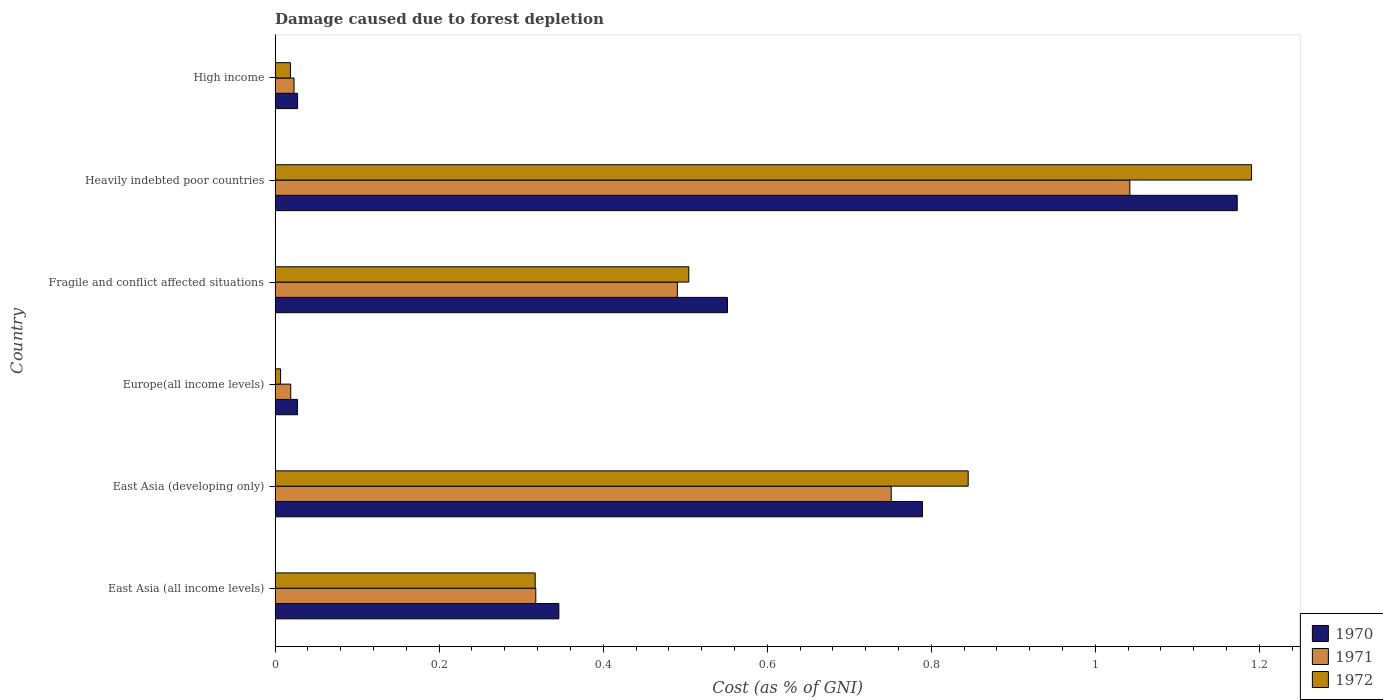How many groups of bars are there?
Your answer should be compact. 6. Are the number of bars per tick equal to the number of legend labels?
Make the answer very short. Yes. How many bars are there on the 1st tick from the top?
Offer a terse response. 3. What is the label of the 4th group of bars from the top?
Give a very brief answer. Europe(all income levels). In how many cases, is the number of bars for a given country not equal to the number of legend labels?
Offer a very short reply. 0. What is the cost of damage caused due to forest depletion in 1971 in East Asia (all income levels)?
Give a very brief answer. 0.32. Across all countries, what is the maximum cost of damage caused due to forest depletion in 1971?
Make the answer very short. 1.04. Across all countries, what is the minimum cost of damage caused due to forest depletion in 1972?
Offer a terse response. 0.01. In which country was the cost of damage caused due to forest depletion in 1972 maximum?
Ensure brevity in your answer.  Heavily indebted poor countries. In which country was the cost of damage caused due to forest depletion in 1971 minimum?
Your answer should be compact. Europe(all income levels). What is the total cost of damage caused due to forest depletion in 1970 in the graph?
Your response must be concise. 2.91. What is the difference between the cost of damage caused due to forest depletion in 1971 in Fragile and conflict affected situations and that in Heavily indebted poor countries?
Your response must be concise. -0.55. What is the difference between the cost of damage caused due to forest depletion in 1971 in Heavily indebted poor countries and the cost of damage caused due to forest depletion in 1970 in East Asia (developing only)?
Your answer should be very brief. 0.25. What is the average cost of damage caused due to forest depletion in 1970 per country?
Offer a very short reply. 0.49. What is the difference between the cost of damage caused due to forest depletion in 1970 and cost of damage caused due to forest depletion in 1971 in East Asia (developing only)?
Your answer should be compact. 0.04. What is the ratio of the cost of damage caused due to forest depletion in 1970 in Europe(all income levels) to that in Heavily indebted poor countries?
Keep it short and to the point. 0.02. Is the cost of damage caused due to forest depletion in 1970 in East Asia (all income levels) less than that in High income?
Offer a very short reply. No. Is the difference between the cost of damage caused due to forest depletion in 1970 in East Asia (all income levels) and High income greater than the difference between the cost of damage caused due to forest depletion in 1971 in East Asia (all income levels) and High income?
Your answer should be compact. Yes. What is the difference between the highest and the second highest cost of damage caused due to forest depletion in 1971?
Provide a short and direct response. 0.29. What is the difference between the highest and the lowest cost of damage caused due to forest depletion in 1972?
Ensure brevity in your answer.  1.18. Is the sum of the cost of damage caused due to forest depletion in 1971 in East Asia (developing only) and Europe(all income levels) greater than the maximum cost of damage caused due to forest depletion in 1970 across all countries?
Ensure brevity in your answer.  No. What does the 3rd bar from the top in East Asia (developing only) represents?
Provide a succinct answer. 1970. Is it the case that in every country, the sum of the cost of damage caused due to forest depletion in 1970 and cost of damage caused due to forest depletion in 1971 is greater than the cost of damage caused due to forest depletion in 1972?
Offer a very short reply. Yes. Are all the bars in the graph horizontal?
Your answer should be compact. Yes. Does the graph contain grids?
Keep it short and to the point. No. What is the title of the graph?
Offer a very short reply. Damage caused due to forest depletion. What is the label or title of the X-axis?
Ensure brevity in your answer.  Cost (as % of GNI). What is the Cost (as % of GNI) of 1970 in East Asia (all income levels)?
Your response must be concise. 0.35. What is the Cost (as % of GNI) in 1971 in East Asia (all income levels)?
Your response must be concise. 0.32. What is the Cost (as % of GNI) of 1972 in East Asia (all income levels)?
Provide a succinct answer. 0.32. What is the Cost (as % of GNI) of 1970 in East Asia (developing only)?
Your answer should be compact. 0.79. What is the Cost (as % of GNI) of 1971 in East Asia (developing only)?
Provide a succinct answer. 0.75. What is the Cost (as % of GNI) in 1972 in East Asia (developing only)?
Offer a very short reply. 0.84. What is the Cost (as % of GNI) of 1970 in Europe(all income levels)?
Ensure brevity in your answer.  0.03. What is the Cost (as % of GNI) in 1971 in Europe(all income levels)?
Your response must be concise. 0.02. What is the Cost (as % of GNI) of 1972 in Europe(all income levels)?
Your response must be concise. 0.01. What is the Cost (as % of GNI) of 1970 in Fragile and conflict affected situations?
Keep it short and to the point. 0.55. What is the Cost (as % of GNI) in 1971 in Fragile and conflict affected situations?
Make the answer very short. 0.49. What is the Cost (as % of GNI) in 1972 in Fragile and conflict affected situations?
Provide a short and direct response. 0.5. What is the Cost (as % of GNI) in 1970 in Heavily indebted poor countries?
Your response must be concise. 1.17. What is the Cost (as % of GNI) of 1971 in Heavily indebted poor countries?
Offer a very short reply. 1.04. What is the Cost (as % of GNI) in 1972 in Heavily indebted poor countries?
Provide a short and direct response. 1.19. What is the Cost (as % of GNI) in 1970 in High income?
Ensure brevity in your answer.  0.03. What is the Cost (as % of GNI) of 1971 in High income?
Keep it short and to the point. 0.02. What is the Cost (as % of GNI) in 1972 in High income?
Your answer should be compact. 0.02. Across all countries, what is the maximum Cost (as % of GNI) in 1970?
Your answer should be compact. 1.17. Across all countries, what is the maximum Cost (as % of GNI) in 1971?
Your answer should be very brief. 1.04. Across all countries, what is the maximum Cost (as % of GNI) in 1972?
Make the answer very short. 1.19. Across all countries, what is the minimum Cost (as % of GNI) in 1970?
Your response must be concise. 0.03. Across all countries, what is the minimum Cost (as % of GNI) in 1971?
Your answer should be compact. 0.02. Across all countries, what is the minimum Cost (as % of GNI) of 1972?
Offer a terse response. 0.01. What is the total Cost (as % of GNI) in 1970 in the graph?
Ensure brevity in your answer.  2.91. What is the total Cost (as % of GNI) of 1971 in the graph?
Ensure brevity in your answer.  2.64. What is the total Cost (as % of GNI) of 1972 in the graph?
Provide a succinct answer. 2.88. What is the difference between the Cost (as % of GNI) of 1970 in East Asia (all income levels) and that in East Asia (developing only)?
Provide a succinct answer. -0.44. What is the difference between the Cost (as % of GNI) in 1971 in East Asia (all income levels) and that in East Asia (developing only)?
Provide a short and direct response. -0.43. What is the difference between the Cost (as % of GNI) of 1972 in East Asia (all income levels) and that in East Asia (developing only)?
Make the answer very short. -0.53. What is the difference between the Cost (as % of GNI) in 1970 in East Asia (all income levels) and that in Europe(all income levels)?
Your response must be concise. 0.32. What is the difference between the Cost (as % of GNI) in 1971 in East Asia (all income levels) and that in Europe(all income levels)?
Keep it short and to the point. 0.3. What is the difference between the Cost (as % of GNI) in 1972 in East Asia (all income levels) and that in Europe(all income levels)?
Ensure brevity in your answer.  0.31. What is the difference between the Cost (as % of GNI) in 1970 in East Asia (all income levels) and that in Fragile and conflict affected situations?
Provide a succinct answer. -0.21. What is the difference between the Cost (as % of GNI) of 1971 in East Asia (all income levels) and that in Fragile and conflict affected situations?
Your answer should be compact. -0.17. What is the difference between the Cost (as % of GNI) of 1972 in East Asia (all income levels) and that in Fragile and conflict affected situations?
Keep it short and to the point. -0.19. What is the difference between the Cost (as % of GNI) in 1970 in East Asia (all income levels) and that in Heavily indebted poor countries?
Offer a very short reply. -0.83. What is the difference between the Cost (as % of GNI) of 1971 in East Asia (all income levels) and that in Heavily indebted poor countries?
Keep it short and to the point. -0.72. What is the difference between the Cost (as % of GNI) in 1972 in East Asia (all income levels) and that in Heavily indebted poor countries?
Make the answer very short. -0.87. What is the difference between the Cost (as % of GNI) in 1970 in East Asia (all income levels) and that in High income?
Provide a short and direct response. 0.32. What is the difference between the Cost (as % of GNI) of 1971 in East Asia (all income levels) and that in High income?
Offer a very short reply. 0.29. What is the difference between the Cost (as % of GNI) of 1972 in East Asia (all income levels) and that in High income?
Offer a terse response. 0.3. What is the difference between the Cost (as % of GNI) in 1970 in East Asia (developing only) and that in Europe(all income levels)?
Make the answer very short. 0.76. What is the difference between the Cost (as % of GNI) in 1971 in East Asia (developing only) and that in Europe(all income levels)?
Your response must be concise. 0.73. What is the difference between the Cost (as % of GNI) in 1972 in East Asia (developing only) and that in Europe(all income levels)?
Provide a succinct answer. 0.84. What is the difference between the Cost (as % of GNI) of 1970 in East Asia (developing only) and that in Fragile and conflict affected situations?
Ensure brevity in your answer.  0.24. What is the difference between the Cost (as % of GNI) in 1971 in East Asia (developing only) and that in Fragile and conflict affected situations?
Keep it short and to the point. 0.26. What is the difference between the Cost (as % of GNI) of 1972 in East Asia (developing only) and that in Fragile and conflict affected situations?
Offer a very short reply. 0.34. What is the difference between the Cost (as % of GNI) of 1970 in East Asia (developing only) and that in Heavily indebted poor countries?
Provide a succinct answer. -0.38. What is the difference between the Cost (as % of GNI) of 1971 in East Asia (developing only) and that in Heavily indebted poor countries?
Your response must be concise. -0.29. What is the difference between the Cost (as % of GNI) in 1972 in East Asia (developing only) and that in Heavily indebted poor countries?
Your answer should be compact. -0.35. What is the difference between the Cost (as % of GNI) in 1970 in East Asia (developing only) and that in High income?
Offer a very short reply. 0.76. What is the difference between the Cost (as % of GNI) of 1971 in East Asia (developing only) and that in High income?
Provide a short and direct response. 0.73. What is the difference between the Cost (as % of GNI) of 1972 in East Asia (developing only) and that in High income?
Keep it short and to the point. 0.83. What is the difference between the Cost (as % of GNI) of 1970 in Europe(all income levels) and that in Fragile and conflict affected situations?
Provide a succinct answer. -0.52. What is the difference between the Cost (as % of GNI) of 1971 in Europe(all income levels) and that in Fragile and conflict affected situations?
Your answer should be very brief. -0.47. What is the difference between the Cost (as % of GNI) in 1972 in Europe(all income levels) and that in Fragile and conflict affected situations?
Provide a succinct answer. -0.5. What is the difference between the Cost (as % of GNI) in 1970 in Europe(all income levels) and that in Heavily indebted poor countries?
Offer a very short reply. -1.15. What is the difference between the Cost (as % of GNI) in 1971 in Europe(all income levels) and that in Heavily indebted poor countries?
Keep it short and to the point. -1.02. What is the difference between the Cost (as % of GNI) of 1972 in Europe(all income levels) and that in Heavily indebted poor countries?
Your response must be concise. -1.18. What is the difference between the Cost (as % of GNI) of 1970 in Europe(all income levels) and that in High income?
Ensure brevity in your answer.  -0. What is the difference between the Cost (as % of GNI) of 1971 in Europe(all income levels) and that in High income?
Offer a very short reply. -0. What is the difference between the Cost (as % of GNI) of 1972 in Europe(all income levels) and that in High income?
Your answer should be compact. -0.01. What is the difference between the Cost (as % of GNI) of 1970 in Fragile and conflict affected situations and that in Heavily indebted poor countries?
Provide a succinct answer. -0.62. What is the difference between the Cost (as % of GNI) of 1971 in Fragile and conflict affected situations and that in Heavily indebted poor countries?
Your response must be concise. -0.55. What is the difference between the Cost (as % of GNI) of 1972 in Fragile and conflict affected situations and that in Heavily indebted poor countries?
Your response must be concise. -0.69. What is the difference between the Cost (as % of GNI) of 1970 in Fragile and conflict affected situations and that in High income?
Offer a very short reply. 0.52. What is the difference between the Cost (as % of GNI) in 1971 in Fragile and conflict affected situations and that in High income?
Your answer should be compact. 0.47. What is the difference between the Cost (as % of GNI) of 1972 in Fragile and conflict affected situations and that in High income?
Give a very brief answer. 0.49. What is the difference between the Cost (as % of GNI) in 1970 in Heavily indebted poor countries and that in High income?
Make the answer very short. 1.15. What is the difference between the Cost (as % of GNI) in 1971 in Heavily indebted poor countries and that in High income?
Offer a terse response. 1.02. What is the difference between the Cost (as % of GNI) in 1972 in Heavily indebted poor countries and that in High income?
Offer a terse response. 1.17. What is the difference between the Cost (as % of GNI) in 1970 in East Asia (all income levels) and the Cost (as % of GNI) in 1971 in East Asia (developing only)?
Keep it short and to the point. -0.41. What is the difference between the Cost (as % of GNI) of 1970 in East Asia (all income levels) and the Cost (as % of GNI) of 1972 in East Asia (developing only)?
Keep it short and to the point. -0.5. What is the difference between the Cost (as % of GNI) of 1971 in East Asia (all income levels) and the Cost (as % of GNI) of 1972 in East Asia (developing only)?
Offer a very short reply. -0.53. What is the difference between the Cost (as % of GNI) of 1970 in East Asia (all income levels) and the Cost (as % of GNI) of 1971 in Europe(all income levels)?
Your answer should be compact. 0.33. What is the difference between the Cost (as % of GNI) of 1970 in East Asia (all income levels) and the Cost (as % of GNI) of 1972 in Europe(all income levels)?
Make the answer very short. 0.34. What is the difference between the Cost (as % of GNI) in 1971 in East Asia (all income levels) and the Cost (as % of GNI) in 1972 in Europe(all income levels)?
Offer a very short reply. 0.31. What is the difference between the Cost (as % of GNI) of 1970 in East Asia (all income levels) and the Cost (as % of GNI) of 1971 in Fragile and conflict affected situations?
Ensure brevity in your answer.  -0.14. What is the difference between the Cost (as % of GNI) of 1970 in East Asia (all income levels) and the Cost (as % of GNI) of 1972 in Fragile and conflict affected situations?
Give a very brief answer. -0.16. What is the difference between the Cost (as % of GNI) in 1971 in East Asia (all income levels) and the Cost (as % of GNI) in 1972 in Fragile and conflict affected situations?
Offer a terse response. -0.19. What is the difference between the Cost (as % of GNI) in 1970 in East Asia (all income levels) and the Cost (as % of GNI) in 1971 in Heavily indebted poor countries?
Give a very brief answer. -0.7. What is the difference between the Cost (as % of GNI) of 1970 in East Asia (all income levels) and the Cost (as % of GNI) of 1972 in Heavily indebted poor countries?
Your answer should be compact. -0.84. What is the difference between the Cost (as % of GNI) in 1971 in East Asia (all income levels) and the Cost (as % of GNI) in 1972 in Heavily indebted poor countries?
Keep it short and to the point. -0.87. What is the difference between the Cost (as % of GNI) of 1970 in East Asia (all income levels) and the Cost (as % of GNI) of 1971 in High income?
Ensure brevity in your answer.  0.32. What is the difference between the Cost (as % of GNI) of 1970 in East Asia (all income levels) and the Cost (as % of GNI) of 1972 in High income?
Offer a terse response. 0.33. What is the difference between the Cost (as % of GNI) of 1971 in East Asia (all income levels) and the Cost (as % of GNI) of 1972 in High income?
Your answer should be very brief. 0.3. What is the difference between the Cost (as % of GNI) of 1970 in East Asia (developing only) and the Cost (as % of GNI) of 1971 in Europe(all income levels)?
Give a very brief answer. 0.77. What is the difference between the Cost (as % of GNI) of 1970 in East Asia (developing only) and the Cost (as % of GNI) of 1972 in Europe(all income levels)?
Your answer should be compact. 0.78. What is the difference between the Cost (as % of GNI) of 1971 in East Asia (developing only) and the Cost (as % of GNI) of 1972 in Europe(all income levels)?
Your response must be concise. 0.74. What is the difference between the Cost (as % of GNI) in 1970 in East Asia (developing only) and the Cost (as % of GNI) in 1971 in Fragile and conflict affected situations?
Ensure brevity in your answer.  0.3. What is the difference between the Cost (as % of GNI) in 1970 in East Asia (developing only) and the Cost (as % of GNI) in 1972 in Fragile and conflict affected situations?
Your response must be concise. 0.28. What is the difference between the Cost (as % of GNI) in 1971 in East Asia (developing only) and the Cost (as % of GNI) in 1972 in Fragile and conflict affected situations?
Give a very brief answer. 0.25. What is the difference between the Cost (as % of GNI) in 1970 in East Asia (developing only) and the Cost (as % of GNI) in 1971 in Heavily indebted poor countries?
Provide a short and direct response. -0.25. What is the difference between the Cost (as % of GNI) in 1970 in East Asia (developing only) and the Cost (as % of GNI) in 1972 in Heavily indebted poor countries?
Your response must be concise. -0.4. What is the difference between the Cost (as % of GNI) in 1971 in East Asia (developing only) and the Cost (as % of GNI) in 1972 in Heavily indebted poor countries?
Make the answer very short. -0.44. What is the difference between the Cost (as % of GNI) in 1970 in East Asia (developing only) and the Cost (as % of GNI) in 1971 in High income?
Offer a very short reply. 0.77. What is the difference between the Cost (as % of GNI) in 1970 in East Asia (developing only) and the Cost (as % of GNI) in 1972 in High income?
Keep it short and to the point. 0.77. What is the difference between the Cost (as % of GNI) in 1971 in East Asia (developing only) and the Cost (as % of GNI) in 1972 in High income?
Keep it short and to the point. 0.73. What is the difference between the Cost (as % of GNI) of 1970 in Europe(all income levels) and the Cost (as % of GNI) of 1971 in Fragile and conflict affected situations?
Your answer should be compact. -0.46. What is the difference between the Cost (as % of GNI) of 1970 in Europe(all income levels) and the Cost (as % of GNI) of 1972 in Fragile and conflict affected situations?
Ensure brevity in your answer.  -0.48. What is the difference between the Cost (as % of GNI) of 1971 in Europe(all income levels) and the Cost (as % of GNI) of 1972 in Fragile and conflict affected situations?
Your response must be concise. -0.49. What is the difference between the Cost (as % of GNI) of 1970 in Europe(all income levels) and the Cost (as % of GNI) of 1971 in Heavily indebted poor countries?
Your answer should be compact. -1.01. What is the difference between the Cost (as % of GNI) of 1970 in Europe(all income levels) and the Cost (as % of GNI) of 1972 in Heavily indebted poor countries?
Provide a short and direct response. -1.16. What is the difference between the Cost (as % of GNI) of 1971 in Europe(all income levels) and the Cost (as % of GNI) of 1972 in Heavily indebted poor countries?
Keep it short and to the point. -1.17. What is the difference between the Cost (as % of GNI) in 1970 in Europe(all income levels) and the Cost (as % of GNI) in 1971 in High income?
Ensure brevity in your answer.  0. What is the difference between the Cost (as % of GNI) of 1970 in Europe(all income levels) and the Cost (as % of GNI) of 1972 in High income?
Your response must be concise. 0.01. What is the difference between the Cost (as % of GNI) of 1970 in Fragile and conflict affected situations and the Cost (as % of GNI) of 1971 in Heavily indebted poor countries?
Provide a short and direct response. -0.49. What is the difference between the Cost (as % of GNI) of 1970 in Fragile and conflict affected situations and the Cost (as % of GNI) of 1972 in Heavily indebted poor countries?
Offer a terse response. -0.64. What is the difference between the Cost (as % of GNI) of 1971 in Fragile and conflict affected situations and the Cost (as % of GNI) of 1972 in Heavily indebted poor countries?
Ensure brevity in your answer.  -0.7. What is the difference between the Cost (as % of GNI) in 1970 in Fragile and conflict affected situations and the Cost (as % of GNI) in 1971 in High income?
Your answer should be very brief. 0.53. What is the difference between the Cost (as % of GNI) in 1970 in Fragile and conflict affected situations and the Cost (as % of GNI) in 1972 in High income?
Ensure brevity in your answer.  0.53. What is the difference between the Cost (as % of GNI) of 1971 in Fragile and conflict affected situations and the Cost (as % of GNI) of 1972 in High income?
Your answer should be very brief. 0.47. What is the difference between the Cost (as % of GNI) in 1970 in Heavily indebted poor countries and the Cost (as % of GNI) in 1971 in High income?
Offer a terse response. 1.15. What is the difference between the Cost (as % of GNI) of 1970 in Heavily indebted poor countries and the Cost (as % of GNI) of 1972 in High income?
Provide a short and direct response. 1.15. What is the difference between the Cost (as % of GNI) of 1971 in Heavily indebted poor countries and the Cost (as % of GNI) of 1972 in High income?
Make the answer very short. 1.02. What is the average Cost (as % of GNI) in 1970 per country?
Your answer should be very brief. 0.49. What is the average Cost (as % of GNI) in 1971 per country?
Provide a short and direct response. 0.44. What is the average Cost (as % of GNI) in 1972 per country?
Ensure brevity in your answer.  0.48. What is the difference between the Cost (as % of GNI) in 1970 and Cost (as % of GNI) in 1971 in East Asia (all income levels)?
Provide a succinct answer. 0.03. What is the difference between the Cost (as % of GNI) in 1970 and Cost (as % of GNI) in 1972 in East Asia (all income levels)?
Provide a short and direct response. 0.03. What is the difference between the Cost (as % of GNI) in 1971 and Cost (as % of GNI) in 1972 in East Asia (all income levels)?
Your answer should be very brief. 0. What is the difference between the Cost (as % of GNI) in 1970 and Cost (as % of GNI) in 1971 in East Asia (developing only)?
Give a very brief answer. 0.04. What is the difference between the Cost (as % of GNI) in 1970 and Cost (as % of GNI) in 1972 in East Asia (developing only)?
Make the answer very short. -0.06. What is the difference between the Cost (as % of GNI) in 1971 and Cost (as % of GNI) in 1972 in East Asia (developing only)?
Keep it short and to the point. -0.09. What is the difference between the Cost (as % of GNI) in 1970 and Cost (as % of GNI) in 1971 in Europe(all income levels)?
Ensure brevity in your answer.  0.01. What is the difference between the Cost (as % of GNI) in 1970 and Cost (as % of GNI) in 1972 in Europe(all income levels)?
Your answer should be compact. 0.02. What is the difference between the Cost (as % of GNI) in 1971 and Cost (as % of GNI) in 1972 in Europe(all income levels)?
Provide a succinct answer. 0.01. What is the difference between the Cost (as % of GNI) in 1970 and Cost (as % of GNI) in 1971 in Fragile and conflict affected situations?
Ensure brevity in your answer.  0.06. What is the difference between the Cost (as % of GNI) of 1970 and Cost (as % of GNI) of 1972 in Fragile and conflict affected situations?
Keep it short and to the point. 0.05. What is the difference between the Cost (as % of GNI) in 1971 and Cost (as % of GNI) in 1972 in Fragile and conflict affected situations?
Your answer should be very brief. -0.01. What is the difference between the Cost (as % of GNI) in 1970 and Cost (as % of GNI) in 1971 in Heavily indebted poor countries?
Your answer should be compact. 0.13. What is the difference between the Cost (as % of GNI) of 1970 and Cost (as % of GNI) of 1972 in Heavily indebted poor countries?
Keep it short and to the point. -0.02. What is the difference between the Cost (as % of GNI) in 1971 and Cost (as % of GNI) in 1972 in Heavily indebted poor countries?
Your answer should be very brief. -0.15. What is the difference between the Cost (as % of GNI) in 1970 and Cost (as % of GNI) in 1971 in High income?
Offer a terse response. 0. What is the difference between the Cost (as % of GNI) of 1970 and Cost (as % of GNI) of 1972 in High income?
Provide a succinct answer. 0.01. What is the difference between the Cost (as % of GNI) in 1971 and Cost (as % of GNI) in 1972 in High income?
Keep it short and to the point. 0. What is the ratio of the Cost (as % of GNI) of 1970 in East Asia (all income levels) to that in East Asia (developing only)?
Ensure brevity in your answer.  0.44. What is the ratio of the Cost (as % of GNI) of 1971 in East Asia (all income levels) to that in East Asia (developing only)?
Provide a short and direct response. 0.42. What is the ratio of the Cost (as % of GNI) in 1972 in East Asia (all income levels) to that in East Asia (developing only)?
Your answer should be compact. 0.38. What is the ratio of the Cost (as % of GNI) of 1970 in East Asia (all income levels) to that in Europe(all income levels)?
Your answer should be very brief. 12.69. What is the ratio of the Cost (as % of GNI) of 1971 in East Asia (all income levels) to that in Europe(all income levels)?
Ensure brevity in your answer.  16.64. What is the ratio of the Cost (as % of GNI) in 1972 in East Asia (all income levels) to that in Europe(all income levels)?
Provide a succinct answer. 47.11. What is the ratio of the Cost (as % of GNI) in 1970 in East Asia (all income levels) to that in Fragile and conflict affected situations?
Offer a terse response. 0.63. What is the ratio of the Cost (as % of GNI) in 1971 in East Asia (all income levels) to that in Fragile and conflict affected situations?
Keep it short and to the point. 0.65. What is the ratio of the Cost (as % of GNI) of 1972 in East Asia (all income levels) to that in Fragile and conflict affected situations?
Provide a short and direct response. 0.63. What is the ratio of the Cost (as % of GNI) of 1970 in East Asia (all income levels) to that in Heavily indebted poor countries?
Your answer should be compact. 0.29. What is the ratio of the Cost (as % of GNI) in 1971 in East Asia (all income levels) to that in Heavily indebted poor countries?
Offer a terse response. 0.3. What is the ratio of the Cost (as % of GNI) of 1972 in East Asia (all income levels) to that in Heavily indebted poor countries?
Provide a short and direct response. 0.27. What is the ratio of the Cost (as % of GNI) of 1970 in East Asia (all income levels) to that in High income?
Provide a succinct answer. 12.62. What is the ratio of the Cost (as % of GNI) in 1971 in East Asia (all income levels) to that in High income?
Provide a succinct answer. 13.75. What is the ratio of the Cost (as % of GNI) of 1972 in East Asia (all income levels) to that in High income?
Ensure brevity in your answer.  16.95. What is the ratio of the Cost (as % of GNI) of 1970 in East Asia (developing only) to that in Europe(all income levels)?
Give a very brief answer. 28.94. What is the ratio of the Cost (as % of GNI) in 1971 in East Asia (developing only) to that in Europe(all income levels)?
Provide a short and direct response. 39.33. What is the ratio of the Cost (as % of GNI) of 1972 in East Asia (developing only) to that in Europe(all income levels)?
Give a very brief answer. 125.54. What is the ratio of the Cost (as % of GNI) in 1970 in East Asia (developing only) to that in Fragile and conflict affected situations?
Provide a succinct answer. 1.43. What is the ratio of the Cost (as % of GNI) in 1971 in East Asia (developing only) to that in Fragile and conflict affected situations?
Make the answer very short. 1.53. What is the ratio of the Cost (as % of GNI) of 1972 in East Asia (developing only) to that in Fragile and conflict affected situations?
Keep it short and to the point. 1.68. What is the ratio of the Cost (as % of GNI) in 1970 in East Asia (developing only) to that in Heavily indebted poor countries?
Your answer should be very brief. 0.67. What is the ratio of the Cost (as % of GNI) of 1971 in East Asia (developing only) to that in Heavily indebted poor countries?
Ensure brevity in your answer.  0.72. What is the ratio of the Cost (as % of GNI) of 1972 in East Asia (developing only) to that in Heavily indebted poor countries?
Your response must be concise. 0.71. What is the ratio of the Cost (as % of GNI) in 1970 in East Asia (developing only) to that in High income?
Provide a short and direct response. 28.78. What is the ratio of the Cost (as % of GNI) of 1971 in East Asia (developing only) to that in High income?
Ensure brevity in your answer.  32.51. What is the ratio of the Cost (as % of GNI) of 1972 in East Asia (developing only) to that in High income?
Keep it short and to the point. 45.15. What is the ratio of the Cost (as % of GNI) of 1970 in Europe(all income levels) to that in Fragile and conflict affected situations?
Your answer should be very brief. 0.05. What is the ratio of the Cost (as % of GNI) of 1971 in Europe(all income levels) to that in Fragile and conflict affected situations?
Your answer should be very brief. 0.04. What is the ratio of the Cost (as % of GNI) of 1972 in Europe(all income levels) to that in Fragile and conflict affected situations?
Ensure brevity in your answer.  0.01. What is the ratio of the Cost (as % of GNI) in 1970 in Europe(all income levels) to that in Heavily indebted poor countries?
Offer a terse response. 0.02. What is the ratio of the Cost (as % of GNI) in 1971 in Europe(all income levels) to that in Heavily indebted poor countries?
Make the answer very short. 0.02. What is the ratio of the Cost (as % of GNI) of 1972 in Europe(all income levels) to that in Heavily indebted poor countries?
Your answer should be very brief. 0.01. What is the ratio of the Cost (as % of GNI) of 1971 in Europe(all income levels) to that in High income?
Your answer should be compact. 0.83. What is the ratio of the Cost (as % of GNI) of 1972 in Europe(all income levels) to that in High income?
Offer a terse response. 0.36. What is the ratio of the Cost (as % of GNI) of 1970 in Fragile and conflict affected situations to that in Heavily indebted poor countries?
Keep it short and to the point. 0.47. What is the ratio of the Cost (as % of GNI) of 1971 in Fragile and conflict affected situations to that in Heavily indebted poor countries?
Give a very brief answer. 0.47. What is the ratio of the Cost (as % of GNI) of 1972 in Fragile and conflict affected situations to that in Heavily indebted poor countries?
Provide a succinct answer. 0.42. What is the ratio of the Cost (as % of GNI) in 1970 in Fragile and conflict affected situations to that in High income?
Offer a very short reply. 20.11. What is the ratio of the Cost (as % of GNI) of 1971 in Fragile and conflict affected situations to that in High income?
Provide a short and direct response. 21.22. What is the ratio of the Cost (as % of GNI) of 1972 in Fragile and conflict affected situations to that in High income?
Offer a very short reply. 26.95. What is the ratio of the Cost (as % of GNI) of 1970 in Heavily indebted poor countries to that in High income?
Your response must be concise. 42.78. What is the ratio of the Cost (as % of GNI) in 1971 in Heavily indebted poor countries to that in High income?
Give a very brief answer. 45.1. What is the ratio of the Cost (as % of GNI) of 1972 in Heavily indebted poor countries to that in High income?
Your answer should be compact. 63.61. What is the difference between the highest and the second highest Cost (as % of GNI) in 1970?
Make the answer very short. 0.38. What is the difference between the highest and the second highest Cost (as % of GNI) in 1971?
Make the answer very short. 0.29. What is the difference between the highest and the second highest Cost (as % of GNI) of 1972?
Provide a succinct answer. 0.35. What is the difference between the highest and the lowest Cost (as % of GNI) in 1970?
Your answer should be very brief. 1.15. What is the difference between the highest and the lowest Cost (as % of GNI) of 1971?
Keep it short and to the point. 1.02. What is the difference between the highest and the lowest Cost (as % of GNI) in 1972?
Offer a very short reply. 1.18. 